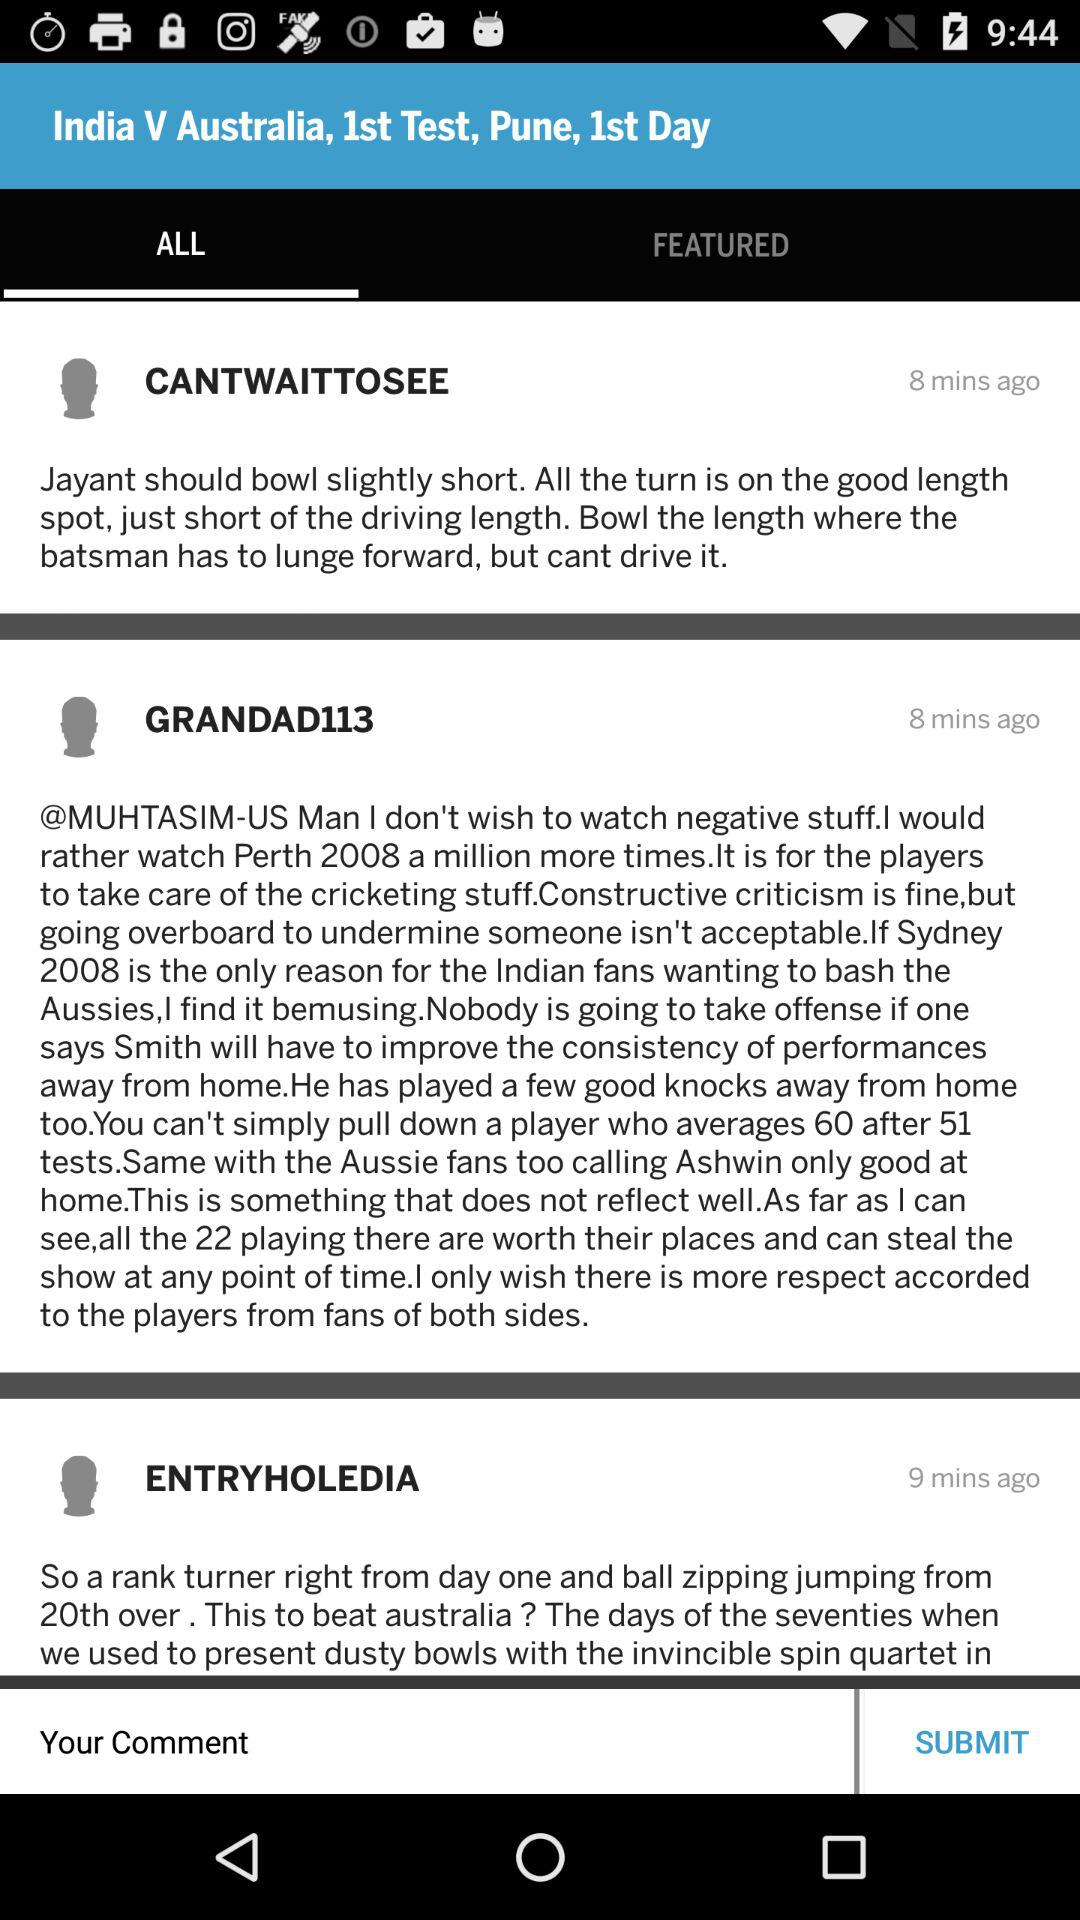Which tab has been selected? The selected tab is "ALL". 